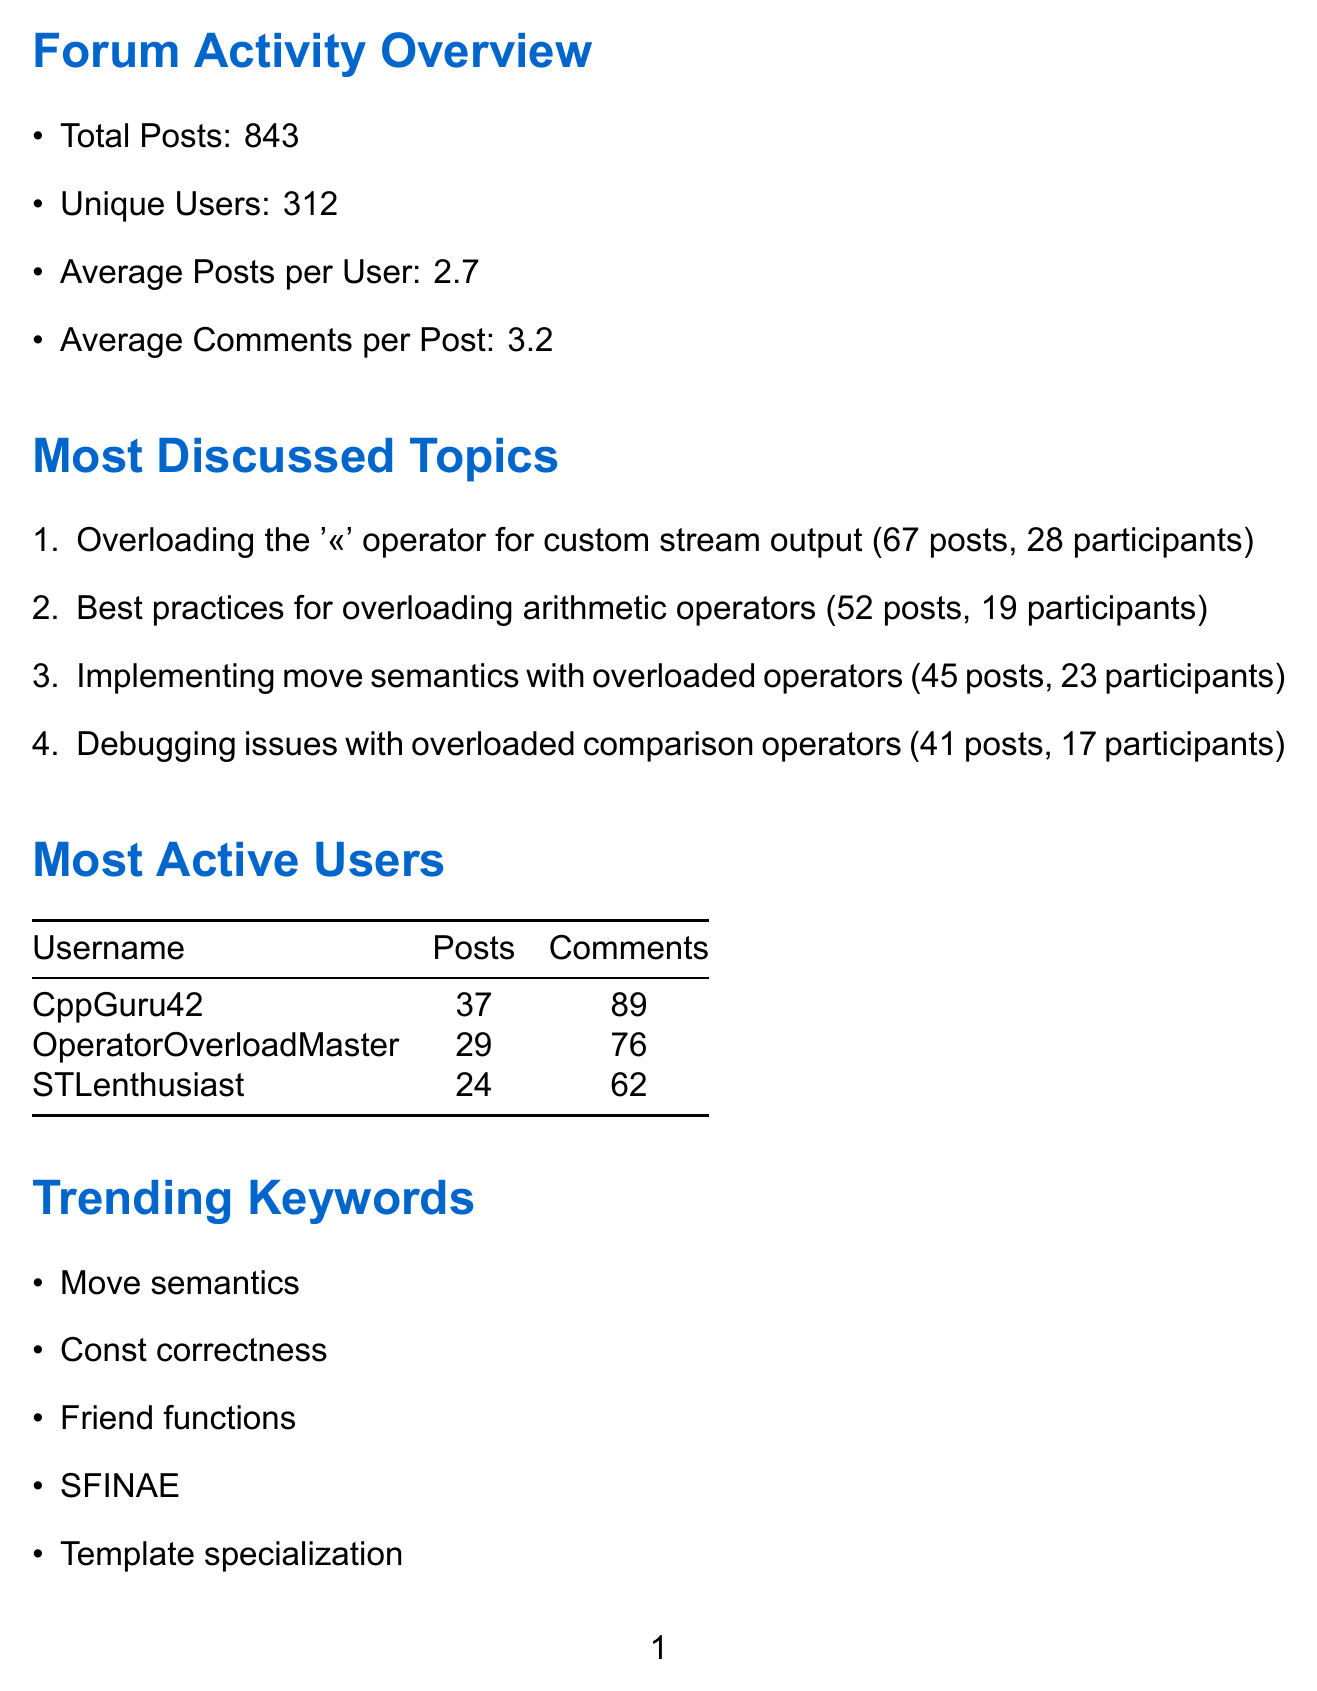What was the total number of posts in May 2023? The total number of posts is listed in the document as 843, which reflects the overall forum discussion activity for that month.
Answer: 843 Who were the three most active users? The document provides a list of the users with the most posts and comments, highlighting their engagement with the forum.
Answer: CppGuru42, OperatorOverloadMaster, STLenthusiast What was the date of the Live Q&A event? The document specifies the date of the event to provide participants with necessary information about scheduled activities.
Answer: May 15, 2023 How many participants attended the Code Review Workshop? The document mentions the number of participants for the community events to show engagement levels during these activities.
Answer: 52 What is the average number of comments per post? The document summarizes user engagement metrics, including how many comments typically come from users for each post.
Answer: 3.2 Which topic had the most posts? The document ranks the discussed topics based on the number of posts, indicating the most popular area of conversation during the month.
Answer: Overloading the '<<' operator for custom stream output How many threads were closed by moderators? The document outlines the actions taken by moderators, providing insight into the management of forum discussions.
Answer: 12 What is one of the upcoming features for the forum? The document lists features intended to be added to enhance user experience and functionality within the forum, signaling improvements on the horizon.
Answer: New syntax highlighting for operator overloading examples 